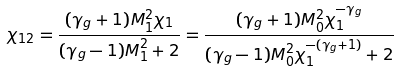<formula> <loc_0><loc_0><loc_500><loc_500>\chi _ { 1 2 } = \frac { ( \gamma _ { g } + 1 ) M _ { 1 } ^ { 2 } \chi _ { 1 } } { ( \gamma _ { g } - 1 ) M _ { 1 } ^ { 2 } + 2 } = \frac { ( \gamma _ { g } + 1 ) M _ { 0 } ^ { 2 } \chi _ { 1 } ^ { - \gamma _ { g } } } { ( \gamma _ { g } - 1 ) M _ { 0 } ^ { 2 } \chi _ { 1 } ^ { - ( \gamma _ { g } + 1 ) } + 2 }</formula> 